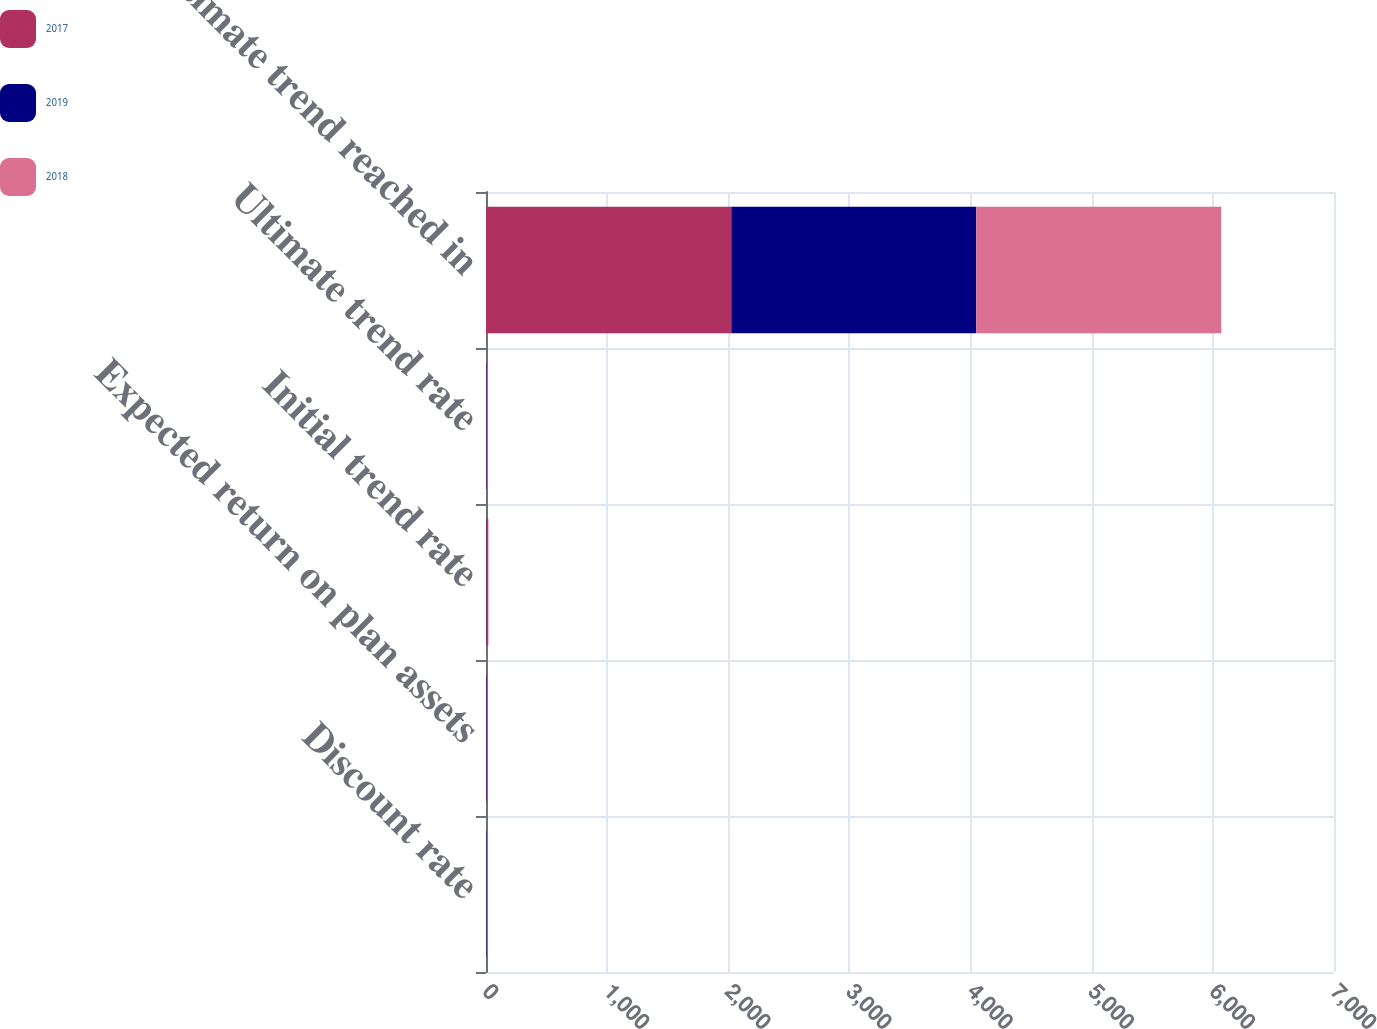Convert chart. <chart><loc_0><loc_0><loc_500><loc_500><stacked_bar_chart><ecel><fcel>Discount rate<fcel>Expected return on plan assets<fcel>Initial trend rate<fcel>Ultimate trend rate<fcel>Ultimate trend reached in<nl><fcel>2017<fcel>3.29<fcel>5.14<fcel>6.25<fcel>5<fcel>2025<nl><fcel>2019<fcel>4.38<fcel>5.33<fcel>6.5<fcel>5<fcel>2022<nl><fcel>2018<fcel>3.73<fcel>4.45<fcel>7.5<fcel>5<fcel>2022<nl></chart> 